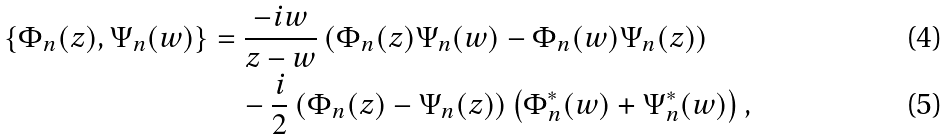Convert formula to latex. <formula><loc_0><loc_0><loc_500><loc_500>\{ \Phi _ { n } ( z ) , \Psi _ { n } ( w ) \} & = \frac { - i w } { z - w } \left ( \Phi _ { n } ( z ) \Psi _ { n } ( w ) - \Phi _ { n } ( w ) \Psi _ { n } ( z ) \right ) \\ & \quad - \frac { i } { 2 } \left ( \Phi _ { n } ( z ) - \Psi _ { n } ( z ) \right ) \left ( \Phi _ { n } ^ { * } ( w ) + \Psi _ { n } ^ { * } ( w ) \right ) ,</formula> 